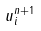Convert formula to latex. <formula><loc_0><loc_0><loc_500><loc_500>u _ { i } ^ { n + 1 }</formula> 